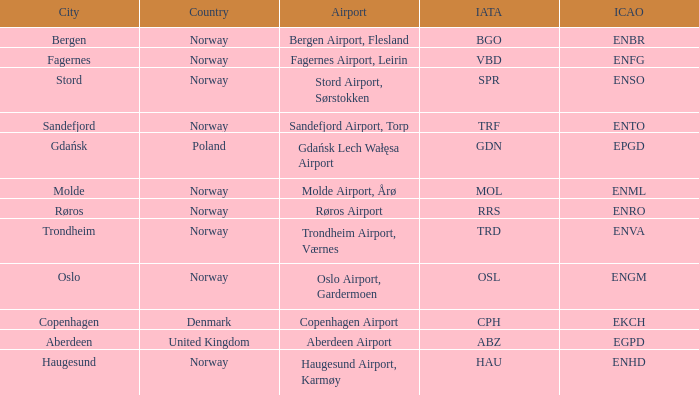In what Country is Haugesund? Norway. 